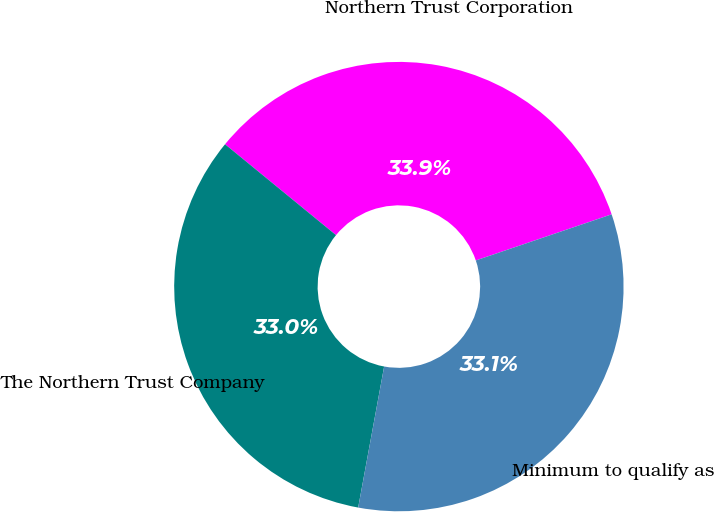Convert chart to OTSL. <chart><loc_0><loc_0><loc_500><loc_500><pie_chart><fcel>Northern Trust Corporation<fcel>The Northern Trust Company<fcel>Minimum to qualify as<nl><fcel>33.87%<fcel>33.02%<fcel>33.11%<nl></chart> 